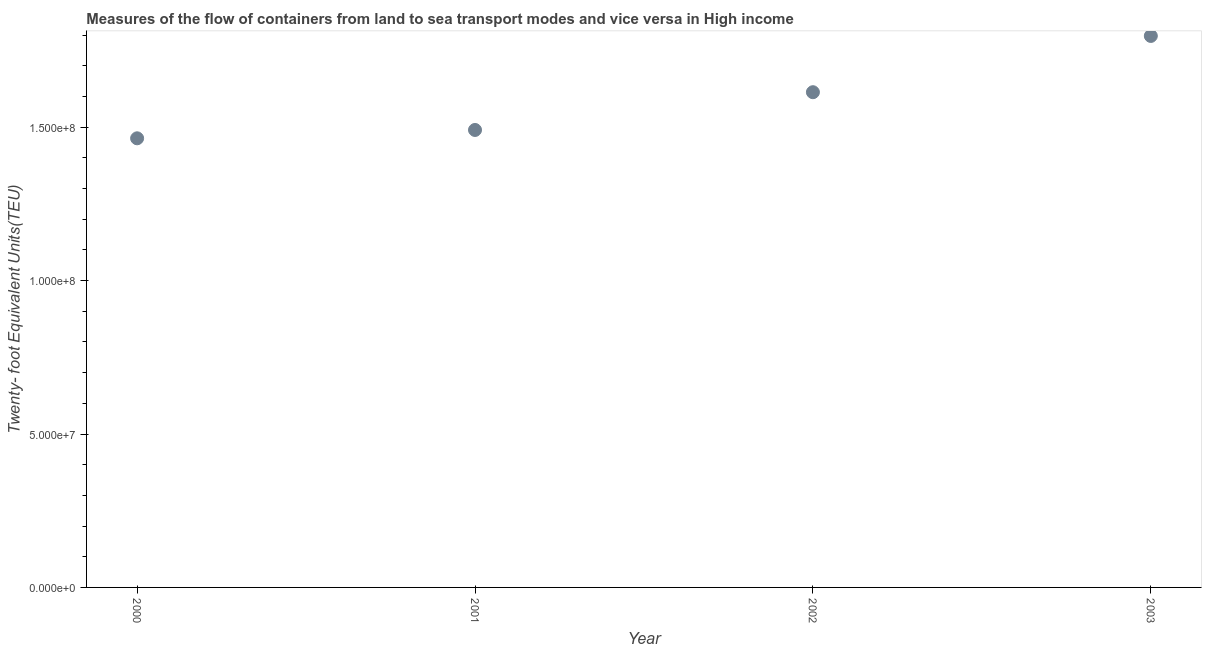What is the container port traffic in 2003?
Give a very brief answer. 1.80e+08. Across all years, what is the maximum container port traffic?
Your answer should be compact. 1.80e+08. Across all years, what is the minimum container port traffic?
Offer a very short reply. 1.46e+08. In which year was the container port traffic maximum?
Your response must be concise. 2003. In which year was the container port traffic minimum?
Offer a terse response. 2000. What is the sum of the container port traffic?
Provide a succinct answer. 6.37e+08. What is the difference between the container port traffic in 2001 and 2003?
Your answer should be compact. -3.06e+07. What is the average container port traffic per year?
Provide a succinct answer. 1.59e+08. What is the median container port traffic?
Make the answer very short. 1.55e+08. In how many years, is the container port traffic greater than 60000000 TEU?
Offer a terse response. 4. What is the ratio of the container port traffic in 2002 to that in 2003?
Provide a short and direct response. 0.9. Is the container port traffic in 2000 less than that in 2002?
Give a very brief answer. Yes. What is the difference between the highest and the second highest container port traffic?
Keep it short and to the point. 1.83e+07. Is the sum of the container port traffic in 2000 and 2001 greater than the maximum container port traffic across all years?
Ensure brevity in your answer.  Yes. What is the difference between the highest and the lowest container port traffic?
Make the answer very short. 3.34e+07. In how many years, is the container port traffic greater than the average container port traffic taken over all years?
Offer a very short reply. 2. How many dotlines are there?
Keep it short and to the point. 1. Does the graph contain any zero values?
Give a very brief answer. No. What is the title of the graph?
Keep it short and to the point. Measures of the flow of containers from land to sea transport modes and vice versa in High income. What is the label or title of the Y-axis?
Offer a terse response. Twenty- foot Equivalent Units(TEU). What is the Twenty- foot Equivalent Units(TEU) in 2000?
Provide a short and direct response. 1.46e+08. What is the Twenty- foot Equivalent Units(TEU) in 2001?
Your answer should be very brief. 1.49e+08. What is the Twenty- foot Equivalent Units(TEU) in 2002?
Give a very brief answer. 1.61e+08. What is the Twenty- foot Equivalent Units(TEU) in 2003?
Give a very brief answer. 1.80e+08. What is the difference between the Twenty- foot Equivalent Units(TEU) in 2000 and 2001?
Provide a succinct answer. -2.72e+06. What is the difference between the Twenty- foot Equivalent Units(TEU) in 2000 and 2002?
Give a very brief answer. -1.50e+07. What is the difference between the Twenty- foot Equivalent Units(TEU) in 2000 and 2003?
Provide a short and direct response. -3.34e+07. What is the difference between the Twenty- foot Equivalent Units(TEU) in 2001 and 2002?
Provide a succinct answer. -1.23e+07. What is the difference between the Twenty- foot Equivalent Units(TEU) in 2001 and 2003?
Make the answer very short. -3.06e+07. What is the difference between the Twenty- foot Equivalent Units(TEU) in 2002 and 2003?
Offer a terse response. -1.83e+07. What is the ratio of the Twenty- foot Equivalent Units(TEU) in 2000 to that in 2002?
Offer a terse response. 0.91. What is the ratio of the Twenty- foot Equivalent Units(TEU) in 2000 to that in 2003?
Give a very brief answer. 0.81. What is the ratio of the Twenty- foot Equivalent Units(TEU) in 2001 to that in 2002?
Offer a very short reply. 0.92. What is the ratio of the Twenty- foot Equivalent Units(TEU) in 2001 to that in 2003?
Keep it short and to the point. 0.83. What is the ratio of the Twenty- foot Equivalent Units(TEU) in 2002 to that in 2003?
Make the answer very short. 0.9. 